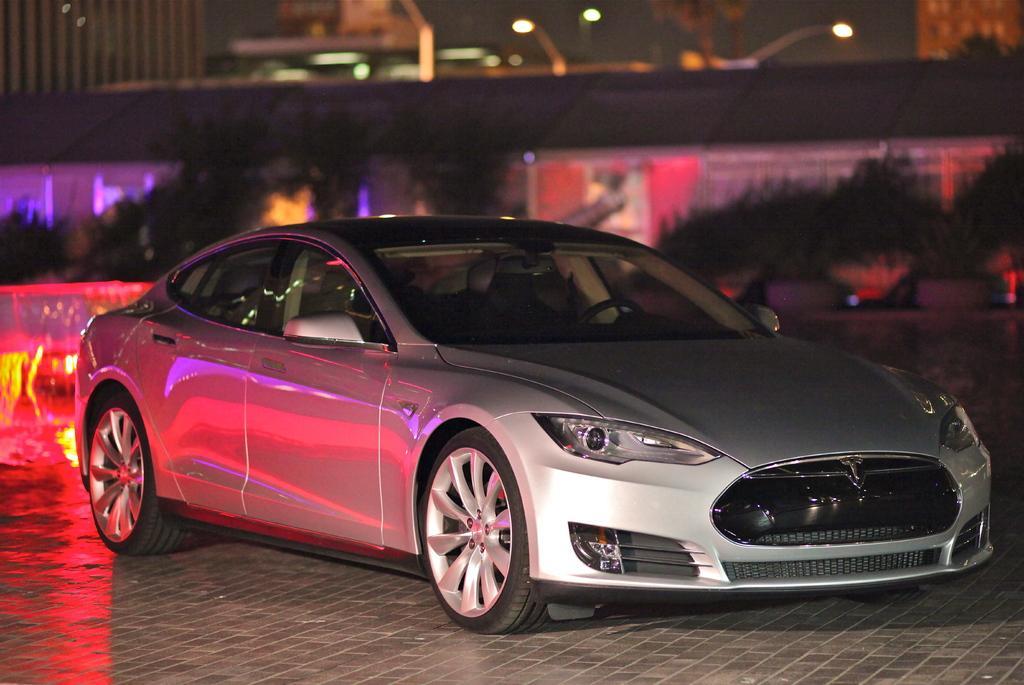Can you describe this image briefly? In this image in the center there is one car, and in the background there are buildings, trees, lights and some objects. At the bottom there is walkway. 